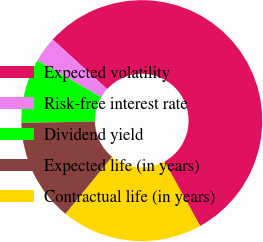Convert chart. <chart><loc_0><loc_0><loc_500><loc_500><pie_chart><fcel>Expected volatility<fcel>Risk-free interest rate<fcel>Dividend yield<fcel>Expected life (in years)<fcel>Contractual life (in years)<nl><fcel>55.2%<fcel>3.44%<fcel>8.61%<fcel>13.79%<fcel>18.96%<nl></chart> 